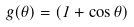<formula> <loc_0><loc_0><loc_500><loc_500>g ( \theta ) = ( 1 + \cos \theta )</formula> 